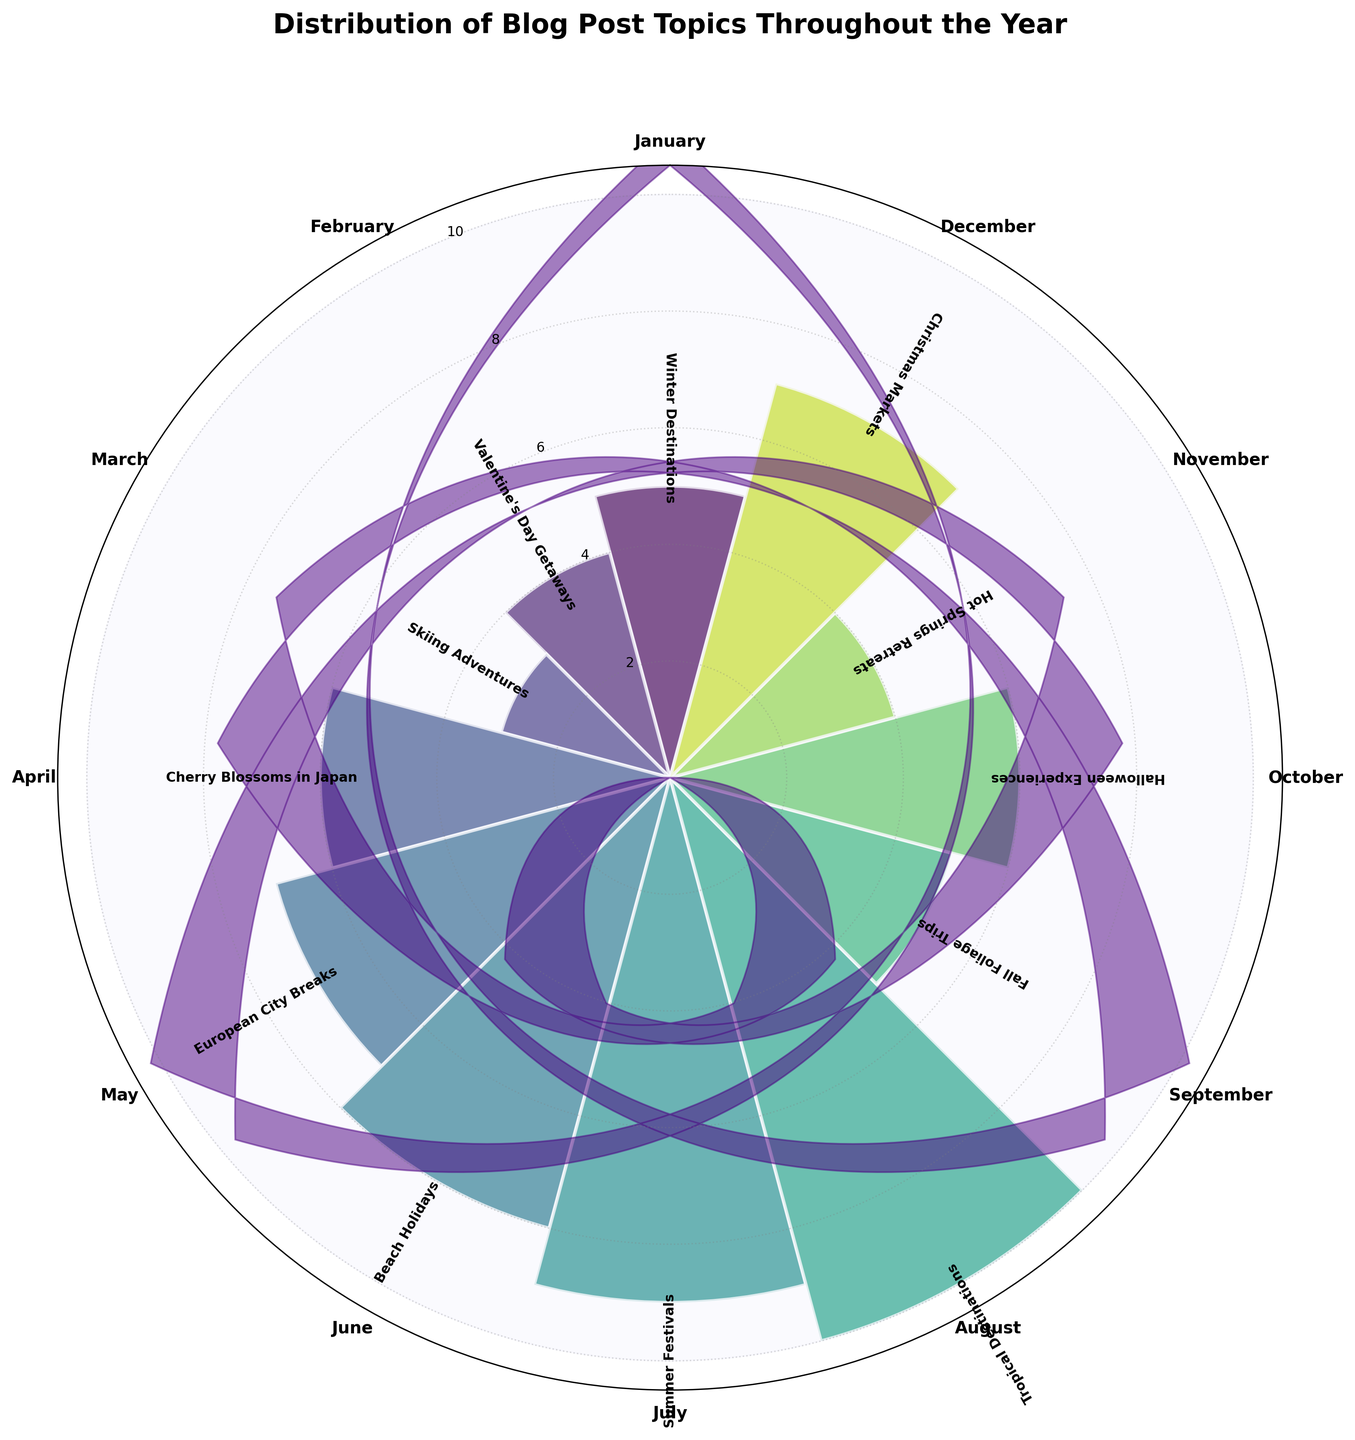How many blog posts were written about Tropical Destinations in August? Looking at the rose chart, you can see that the section for August (which is labeled as Tropical Destinations) extends outward to where the value indicator shows 10. Therefore, there are 10 blog posts on Tropical Destinations in August.
Answer: 10 Which month had the most posts about seasonal activities, and how many were there? Seasonal activities like Summer Festivals, Fall Foliage Trips, and Christmas Markets are part of different months. The section for July (Summer Festivals) extends the furthest showing the maximum value indicator of 9. So, July had the most posts about seasonal activities with 9 posts.
Answer: July, 9 What is the cumulative number of blog posts for topics from June to August? The rose chart shows counts of 8 for June, 9 for July, and 10 for August. Adding these values together, 8 + 9 + 10 equals 27.
Answer: 27 How do the number of posts about European City Breaks in May compare to those about Cherry Blossoms in Japan in April? To compare, the rose chart shows that May (European City Breaks) has 7 posts and April (Cherry Blossoms in Japan) has 6 posts. Therefore, there is 1 more post about European City Breaks in May than Cherry Blossoms in April.
Answer: May has 1 more post Is there a month with the same number of posts about hot springs retreats as Valentine's Day getaways? If so, what is it? From the rose chart, Valentine's Day Getaways in February has 4 posts. The month of November (Hot Springs Retreats) also has 4 posts, making them equal.
Answer: November What percentage of the total posts are about Beach Holidays in June? First, calculate the total number of posts by summing all segments: 5 (Jan) + 4 (Feb) + 3 (Mar) + 6 (Apr) + 7 (May) + 8 (Jun) + 9 (Jul) + 10 (Aug) + 5 (Sep) + 6 (Oct) + 4 (Nov) + 7 (Dec) = 74. Then, the percentage for June is (8 / 74) * 100 ≈ 10.81%.
Answer: 10.81% Which blog post topic has the least count and in which month does it occur? By observing the rose chart, the smallest section corresponds to Skiing Adventures in March, which shows a value of 3.
Answer: Skiing Adventures in March Is there a month where the number of blog posts is exactly halfway between the highest and lowest counts? The highest count is 10 (August) and the lowest count is 3 (March). Halfway between 10 and 3 is (10 + 3) / 2 = 6.5. The rose chart shows that no month has exactly 6.5 posts.
Answer: No How many more posts were published about Halloween Experiences in October compared to Hot Springs Retreats in November? The chart shows that October (Halloween Experiences) has 6 posts, and November (Hot Springs Retreats) has 4 posts. The difference is 6 - 4 = 2.
Answer: 2 